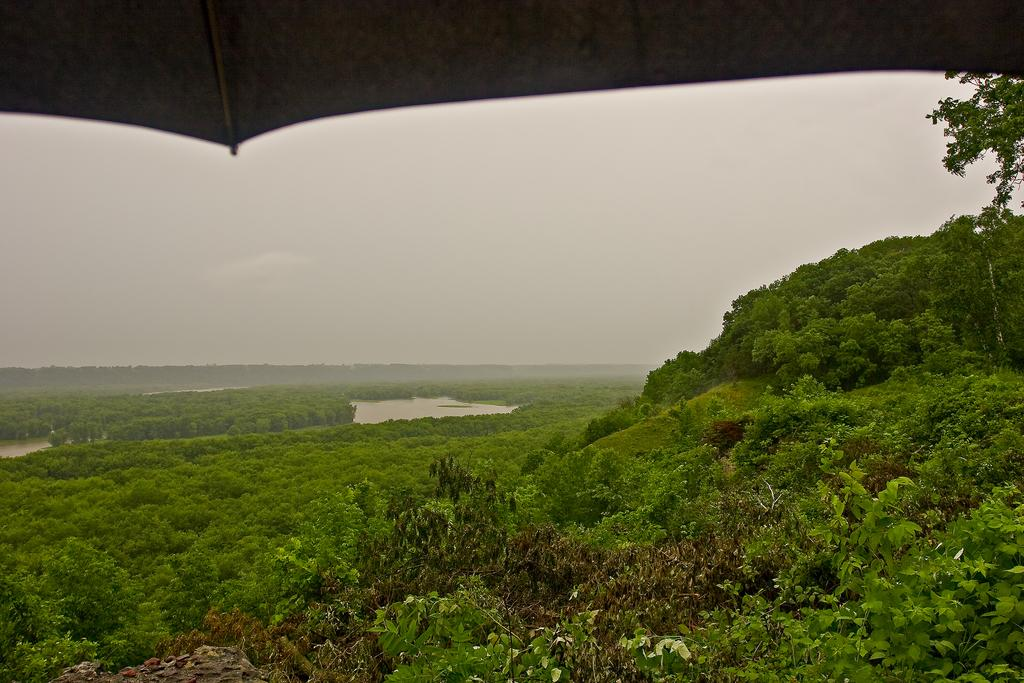What type of vegetation can be seen in the image? There are trees in the image. What natural element is visible in the image? There is water visible in the image. What can be seen in the distance in the image? There are: There are hills in the background of the image. How would you describe the sky in the image? The sky is cloudy in the background of the image. What object is present at the top of the image? There is an umbrella at the top of the image. Who is the creator of the egg in the image? There is no egg present in the image. What type of attraction can be seen in the image? There is no attraction present in the image; it features trees, water, hills, a cloudy sky, and an umbrella. 